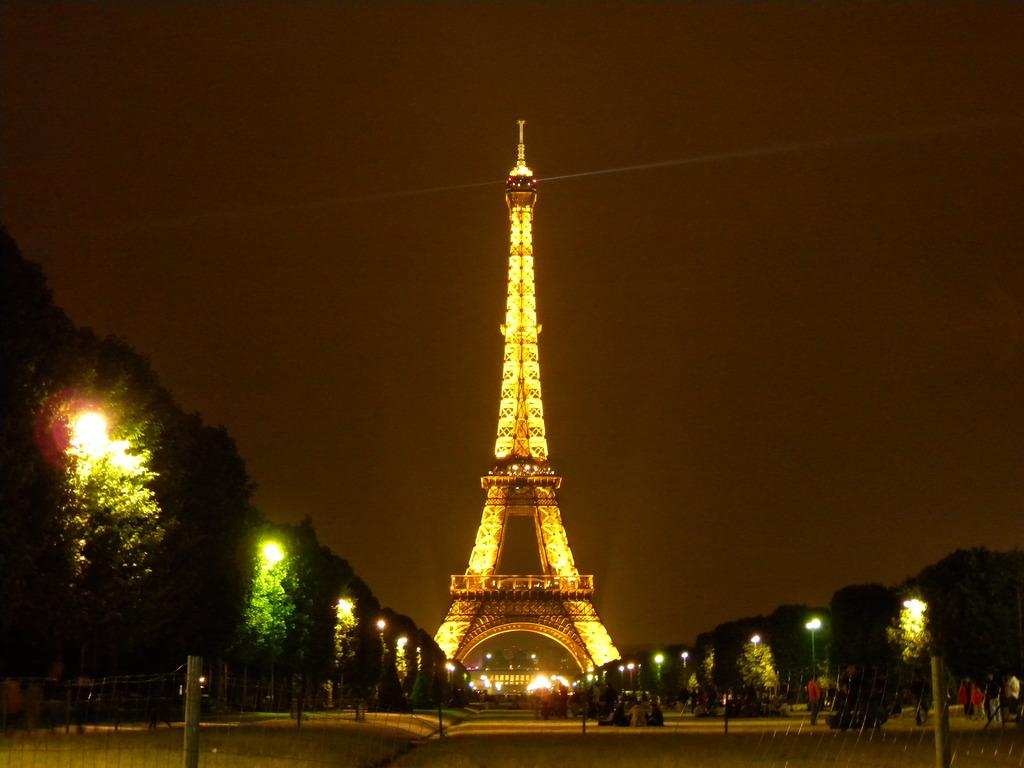What is the main structure in the picture? There is a tower in the picture. What type of vegetation can be seen in the picture? There are trees in the picture. What are the poles with lights used for in the picture? The poles with lights are likely used for illumination in the picture. What are the people in the picture doing? The people in the picture are walking on the roads. What type of lizards can be seen climbing on the tower in the picture? There are no lizards present in the picture; it only features a tower, trees, poles with lights, and people walking on the roads. 